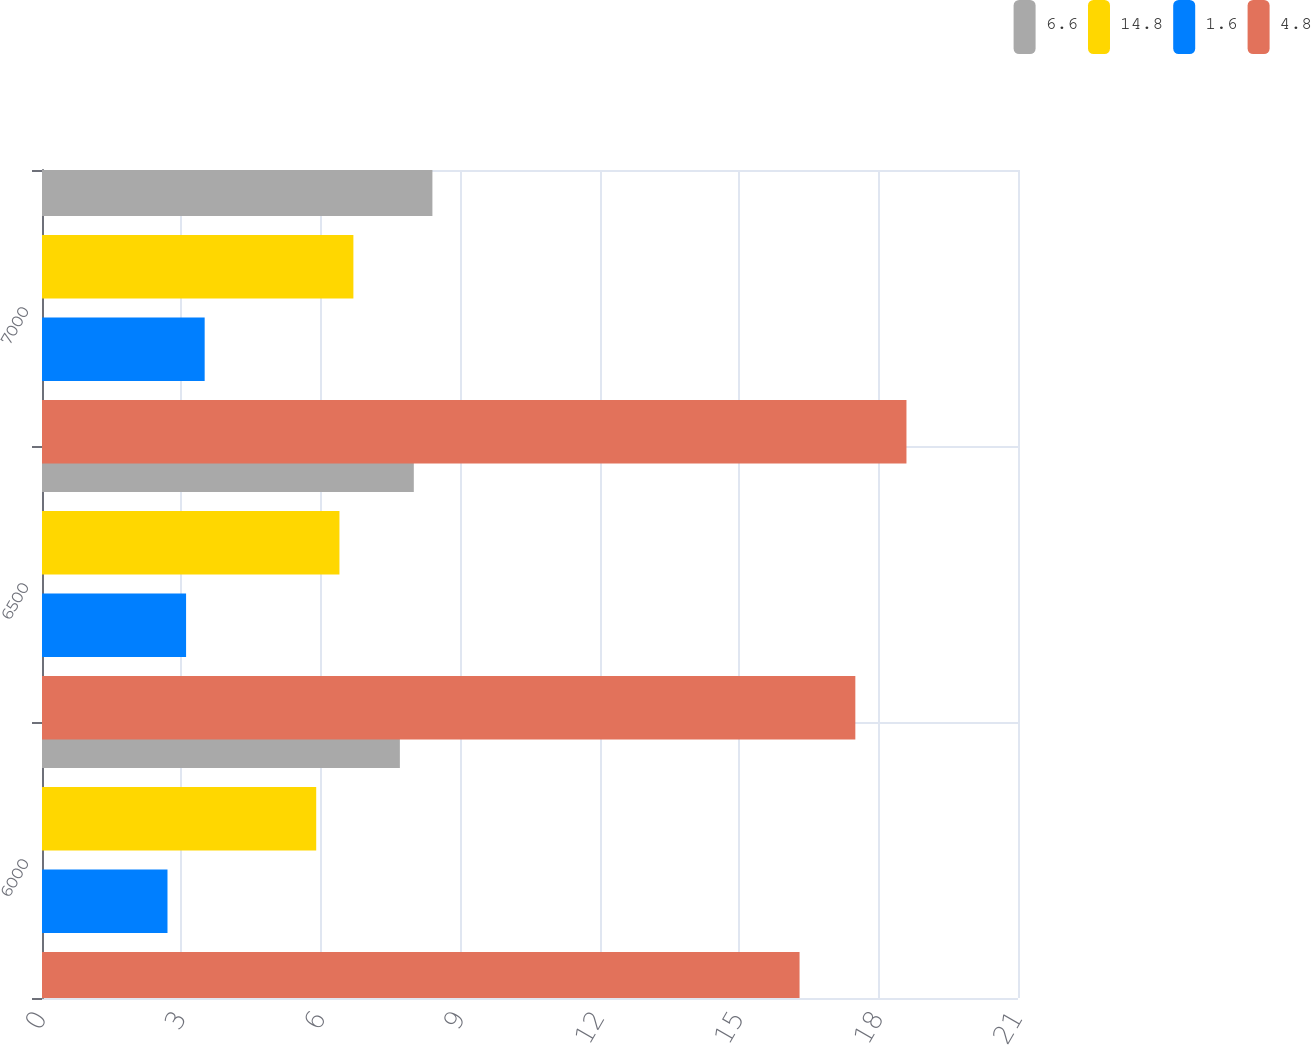Convert chart. <chart><loc_0><loc_0><loc_500><loc_500><stacked_bar_chart><ecel><fcel>6000<fcel>6500<fcel>7000<nl><fcel>6.6<fcel>7.7<fcel>8<fcel>8.4<nl><fcel>14.8<fcel>5.9<fcel>6.4<fcel>6.7<nl><fcel>1.6<fcel>2.7<fcel>3.1<fcel>3.5<nl><fcel>4.8<fcel>16.3<fcel>17.5<fcel>18.6<nl></chart> 